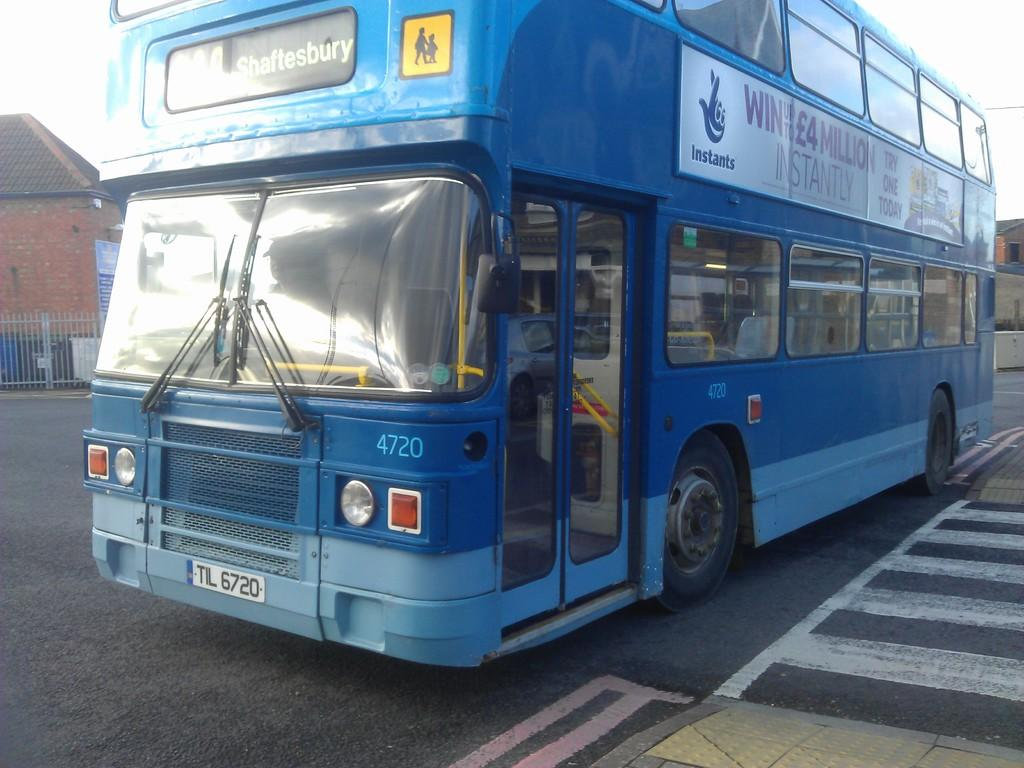What type of vehicle is in the image? There is a blue color bus in the image. Where is the bus located? The bus is on the road. What can be seen on the left side of the image? There is a brick wall on the left side of the image. How many ducks are swimming in the wilderness in the image? There are no ducks or wilderness present in the image; it features a blue color bus on the road with a brick wall on the left side. 